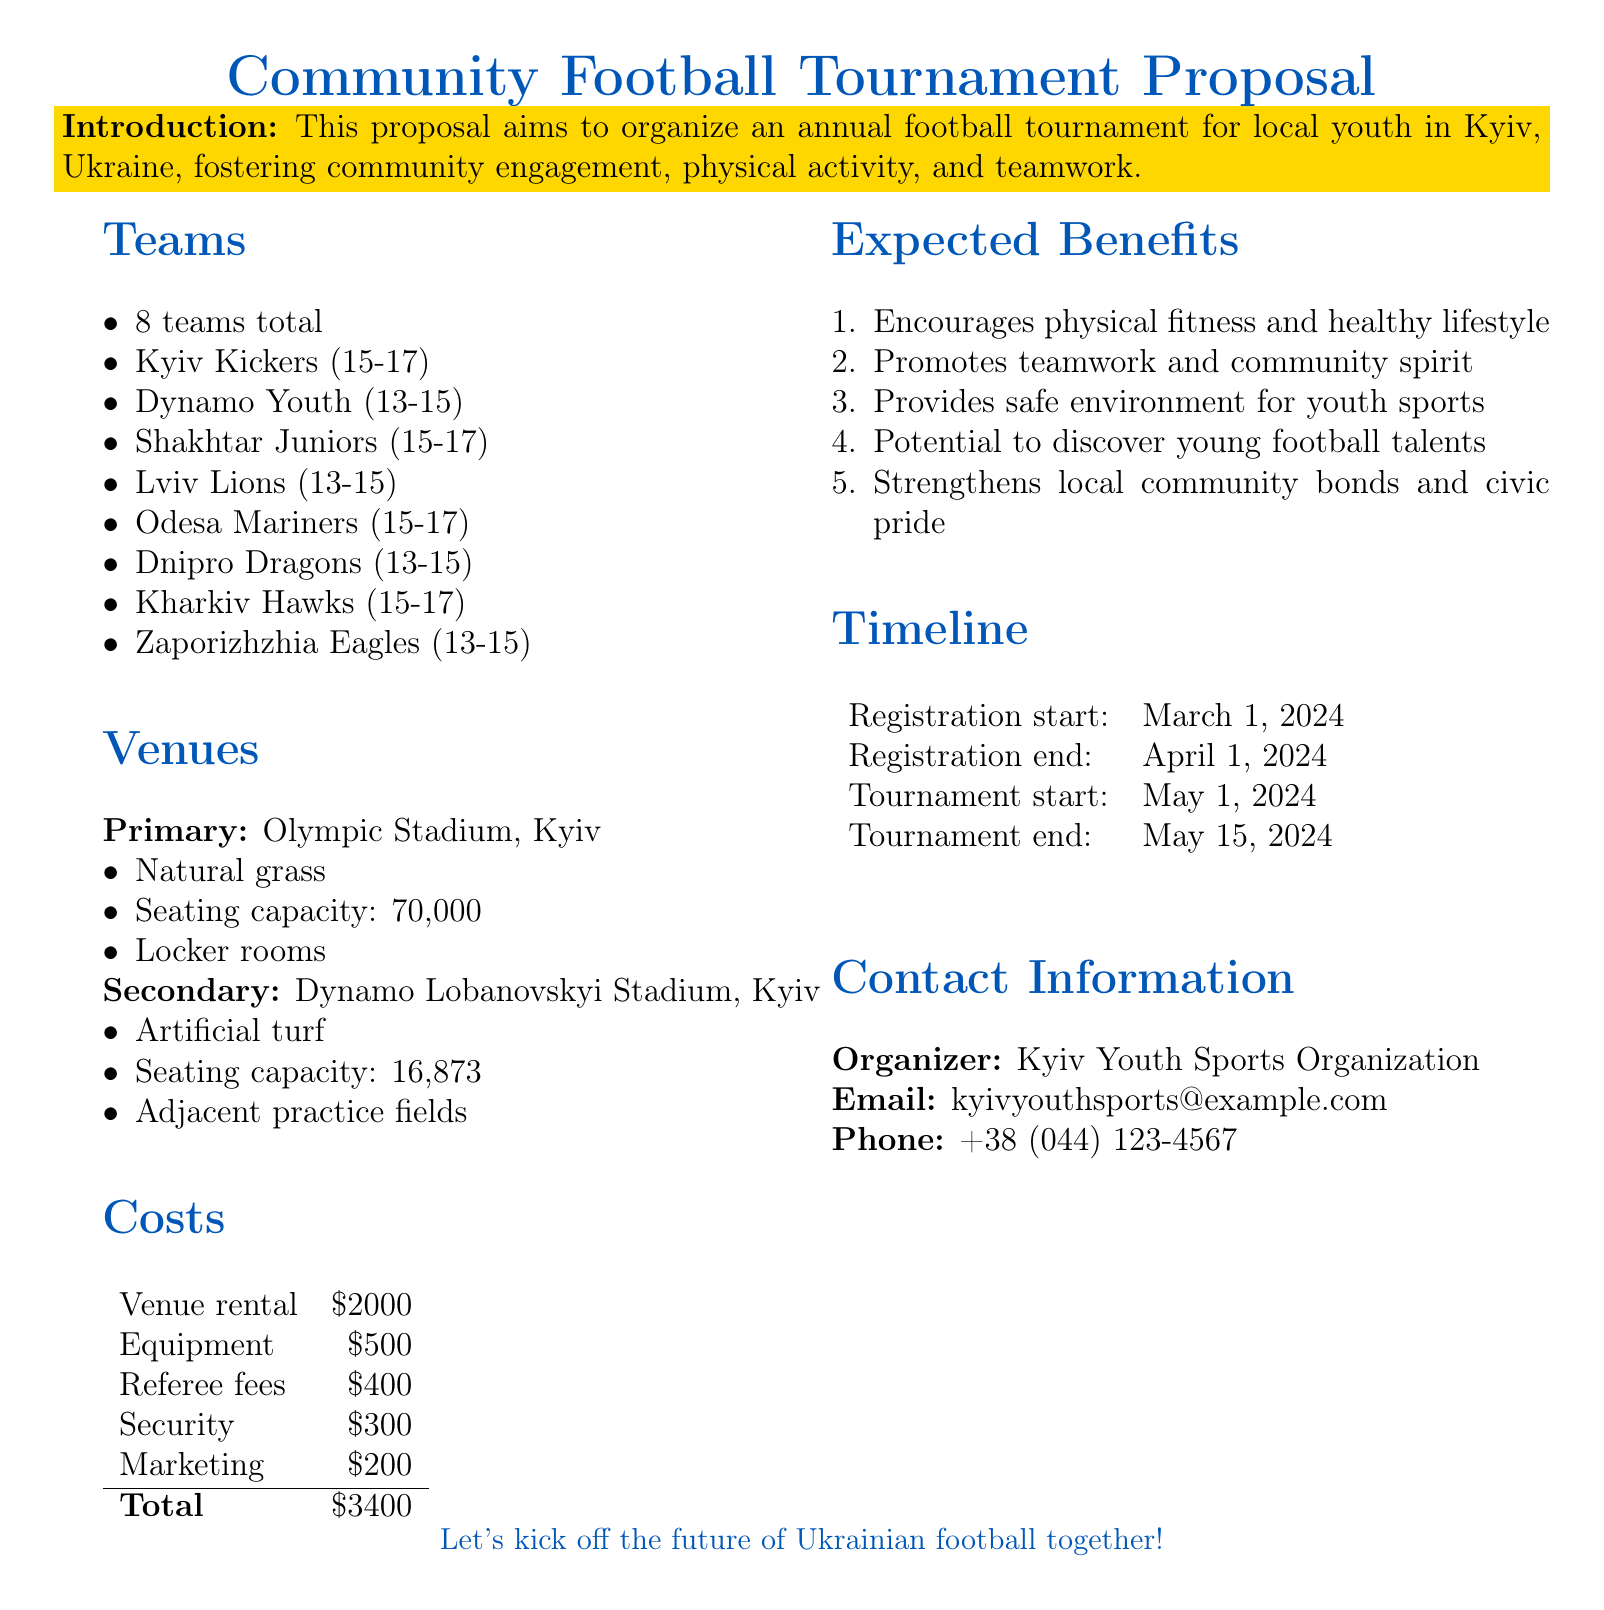what is the total number of teams? The document states that there are 8 teams participating in the tournament.
Answer: 8 what is the name of the primary venue? The primary venue mentioned in the document is the Olympic Stadium.
Answer: Olympic Stadium what is the seating capacity of the Dynamo Lobanovskyi Stadium? The document specifies that the seating capacity of the Dynamo Lobanovskyi Stadium is 16,873.
Answer: 16,873 how much is allocated for referee fees? The total allocated for referee fees in the document is presented as $400.
Answer: $400 when does the tournament start? The document indicates that the tournament starts on May 1, 2024.
Answer: May 1, 2024 what is one expected benefit of the tournament? The document lists multiple expected benefits, one of which is promoting teamwork and community spirit.
Answer: Promotes teamwork and community spirit who is the organizer of the tournament? The document identifies the organizer as Kyiv Youth Sports Organization.
Answer: Kyiv Youth Sports Organization what is the total cost for organizing the tournament? The total cost for organizing the tournament is calculated in the document as $3,400.
Answer: $3,400 